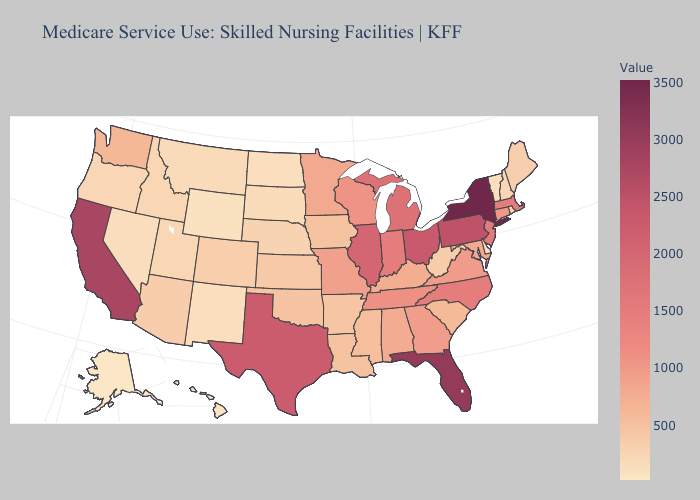Does the map have missing data?
Write a very short answer. No. Does the map have missing data?
Give a very brief answer. No. Does Maryland have a lower value than Montana?
Give a very brief answer. No. Which states have the highest value in the USA?
Give a very brief answer. New York. Does Illinois have the lowest value in the MidWest?
Answer briefly. No. 